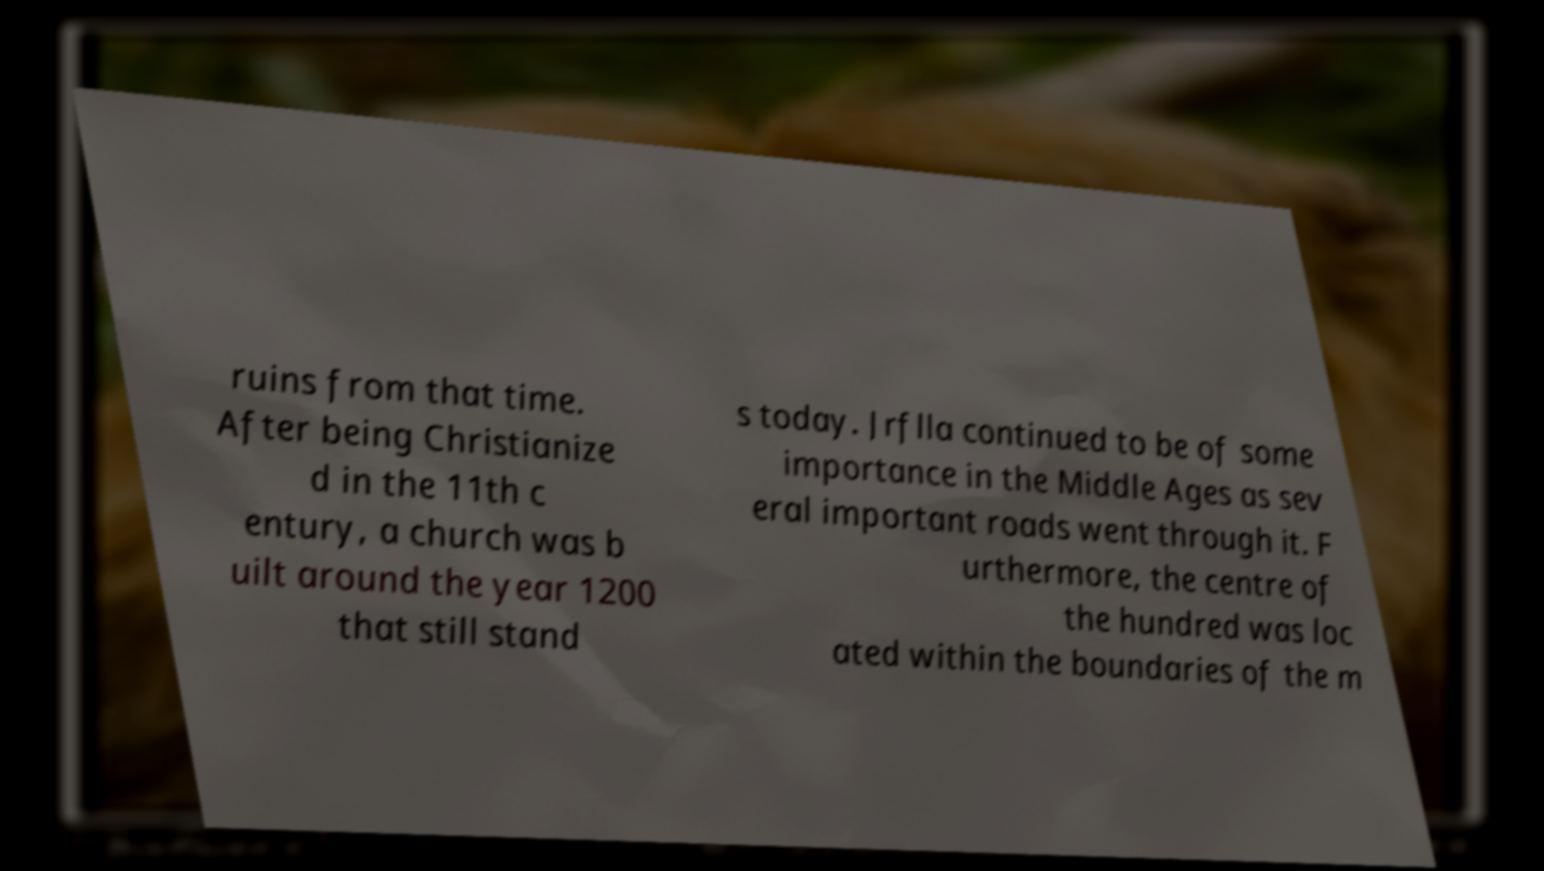Please read and relay the text visible in this image. What does it say? ruins from that time. After being Christianize d in the 11th c entury, a church was b uilt around the year 1200 that still stand s today. Jrflla continued to be of some importance in the Middle Ages as sev eral important roads went through it. F urthermore, the centre of the hundred was loc ated within the boundaries of the m 